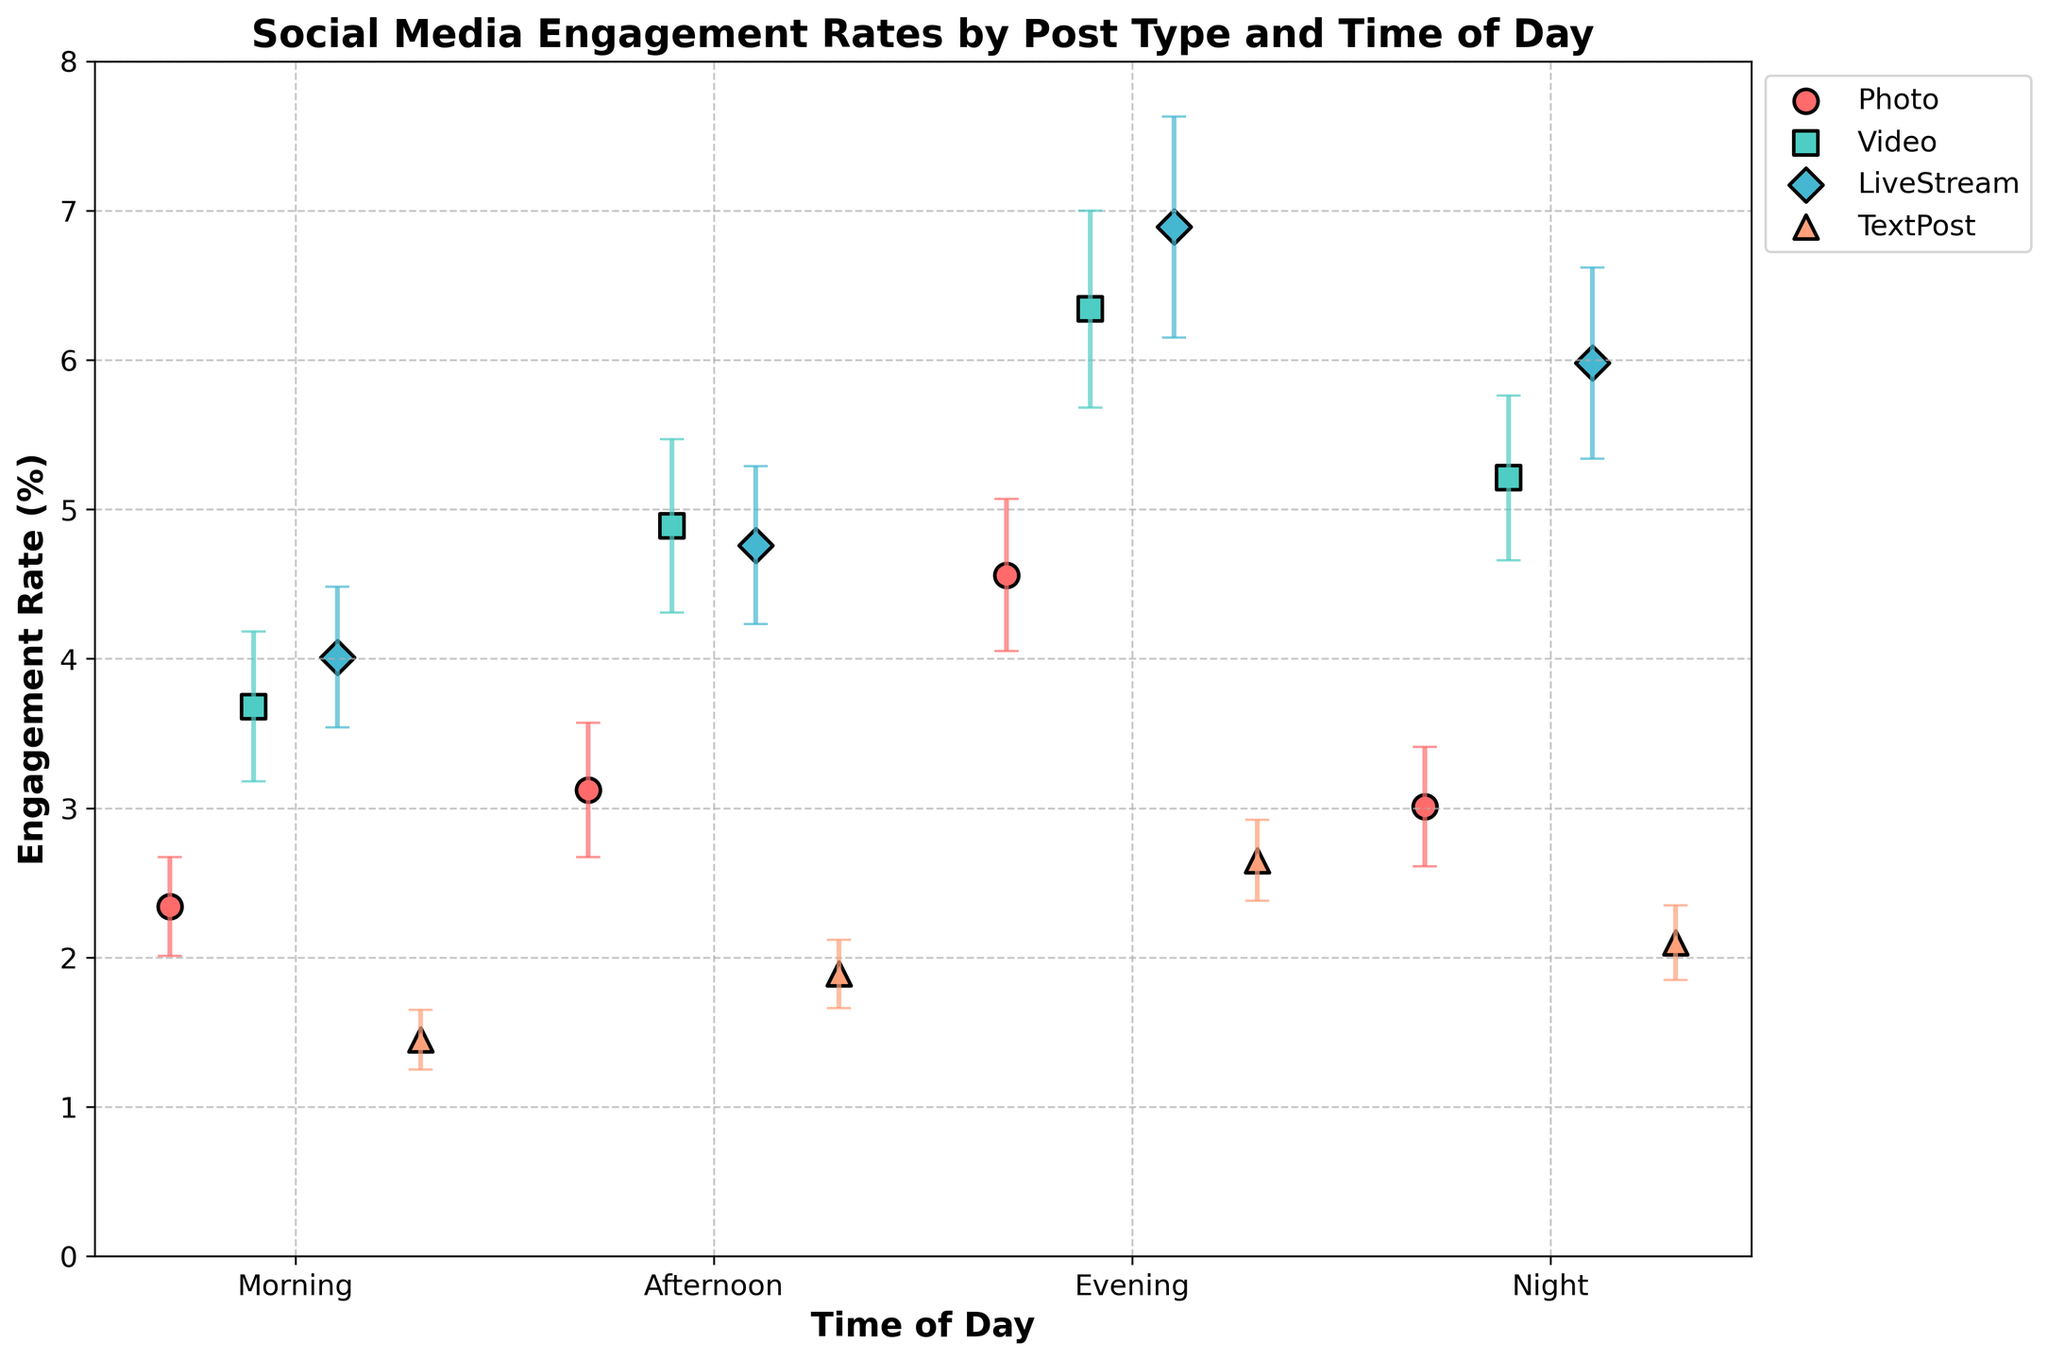How many different post types are shown in the figure? The figure has markers that represent different post types, each with unique shapes and colors. By counting these distinct markers in the legend, we see there are four post types: Photo, Video, LiveStream, and TextPost.
Answer: Four Which time of day has the highest engagement rate for Video posts? To find the highest engagement rate for Video posts, we look at the Video plot markers and identify the one with the maximum y-value. The highest point is in the Evening.
Answer: Evening What is the engagement rate difference between LiveStream and TextPost in the Morning? Locate the Morning data points for both LiveStream and TextPost. The engagement rates are 4.01 for LiveStream and 1.45 for TextPost. The difference is calculated as 4.01 - 1.45.
Answer: 2.56 What is the average engagement rate for Photo posts across all time slots? Sum the engagement rates for Photo posts (2.34, 3.12, 4.56, 3.01) and divide by the number of time slots (4). Calculation: (2.34 + 3.12 + 4.56 + 3.01) / 4.
Answer: 3.26 Which post type has the least engagement rate in the Evening, and what is the rate? Check the engagement rates for all post types in the Evening. The rates are 4.56 for Photo, 6.34 for Video, 6.89 for LiveStream, and 2.65 for TextPost. The lowest rate is for TextPost.
Answer: TextPost, 2.65 How does the engagement rate for LiveStream posts at Night compare to Video posts at Night? Identify the engagement rates for LiveStream (5.98) and Video (5.21) at Night. Compare them to see that LiveStream has a higher engagement rate.
Answer: LiveStream has a higher engagement rate What is the total error bar value for TextPost in the Afternoon? Find the standard error for TextPost in the Afternoon, which is 0.23, and multiply it by 2 to account for both directions of the error bar. Calculation: 0.23 * 2.
Answer: 0.46 Which post type shows the largest variance in engagement rates across all times of day? Calculate the variance for each post type across times of day and compare. LiveStream engagement rates (4.01, 4.76, 6.89, 5.98) have a larger spread compared to other post types.
Answer: LiveStream How much higher is the engagement rate of LiveStream posts in the Evening compared to the Morning? The engagement rates are 6.89 in the Evening and 4.01 in the Morning. The difference is calculated as 6.89 - 4.01.
Answer: 2.88 